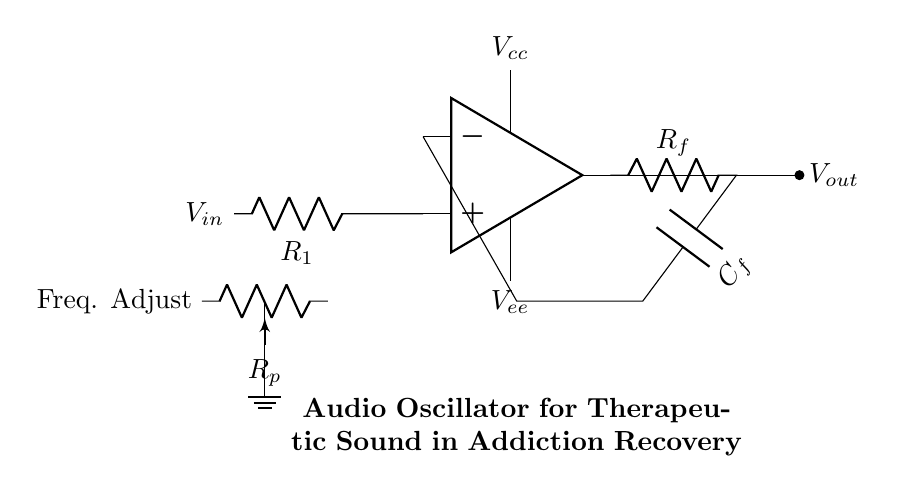What is the type of circuit shown? The circuit is an audio oscillator, which generates periodic wave signals for therapeutic applications.
Answer: audio oscillator What is the purpose of the potentiometer in the circuit? The potentiometer adjusts the frequency of the oscillator, allowing the user to fine-tune the sound frequency generated based on therapeutic needs.
Answer: frequency adjust What are the supply voltages used in this circuit? The circuit uses two supply voltages: Vcc and Vee, which power the operational amplifier.
Answer: Vcc, Vee What component is used for feedback in the oscillator circuit? The feedback network consists of a resistor and a capacitor, specifically Rf and Cf, which together determine the stability and frequency of the oscillation.
Answer: Rf, Cf How many resistors are present in this circuit? There are three resistors: R1, Rf, and Rp, which all play crucial roles in the oscillator's operation and frequency control.
Answer: three resistors What is the output of the circuit? The output of the circuit is represented as Vout, which is the amplified signal generated based on the oscillator's configuration and frequencies.
Answer: Vout Why is the connection from op-amp out to Rf important? This connection is crucial as it creates a feedback loop essential for oscillation, stabilizing the output signal and determining the overall frequency characteristics of the circuit.
Answer: feedback loop 